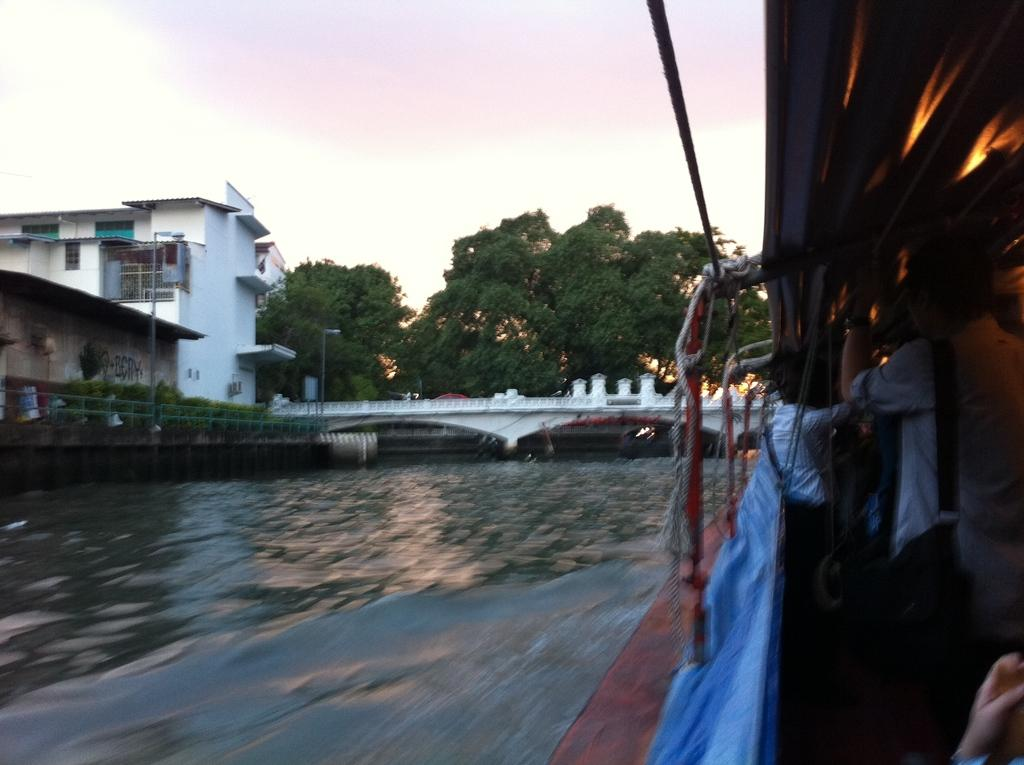What is located on the right side of the image? There is a boat on the right side of the image. Who or what is on the boat? There are people on the boat. What can be seen at the bottom of the image? Waves and water are visible at the bottom of the image. What is present in the middle of the image? Trees, a bridge, houses, and the sky are visible in the middle of the image. What type of test is being conducted on the boat in the image? There is no test being conducted on the boat in the image. What color is the cloud in the image? There is no cloud present in the image. 